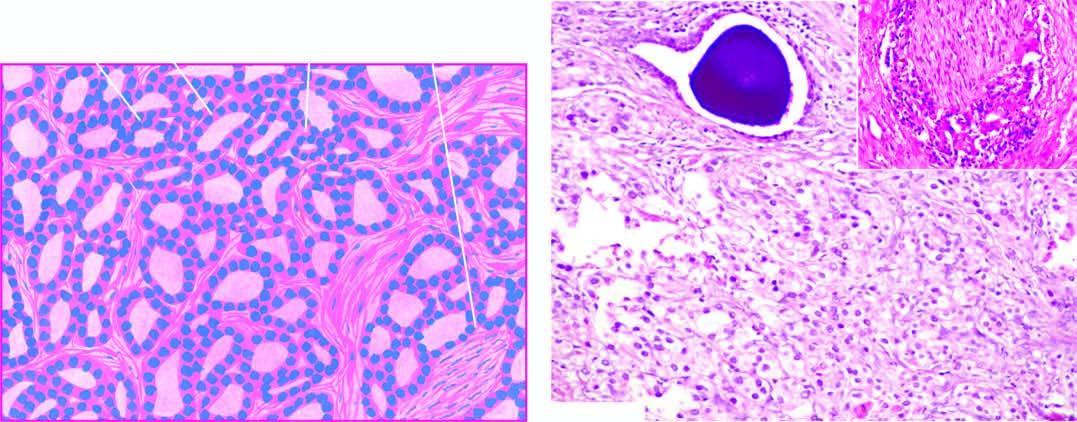does 2,3-bpg and co2 show microacini of small malignant cells infiltrating the prostatic stroma?
Answer the question using a single word or phrase. No 